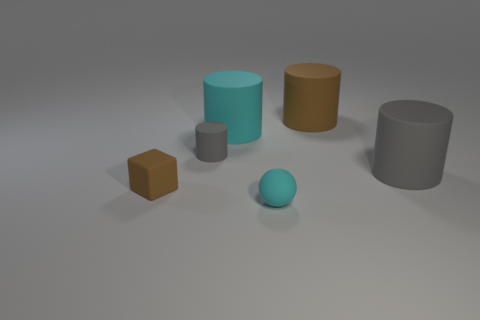If these objects were to be used in a real-world scenario, what could they represent? In a real-world setting, the cylinders might represent containers or storage items, while the cubes could be packages or building blocks. Their matte textures suggest they could also be prototypes used for design spacing and concept visualization. 